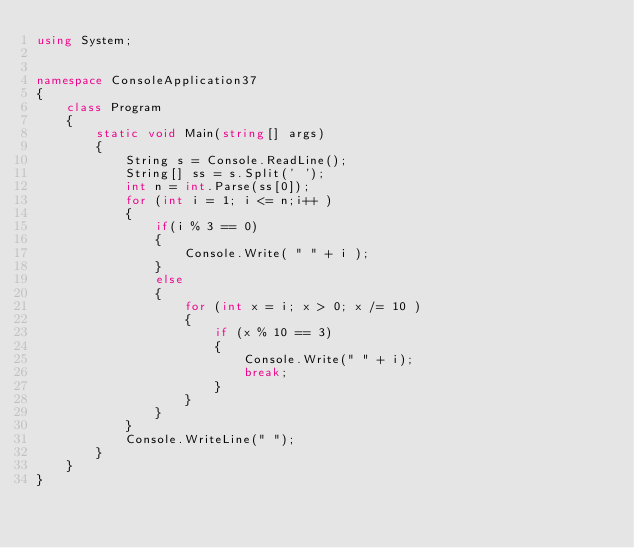<code> <loc_0><loc_0><loc_500><loc_500><_C#_>using System;


namespace ConsoleApplication37
{
    class Program
    {
        static void Main(string[] args)
        {
            String s = Console.ReadLine();
            String[] ss = s.Split(' ');
            int n = int.Parse(ss[0]);
            for (int i = 1; i <= n;i++ )
            {
                if(i % 3 == 0)
                {
                    Console.Write( " " + i );
                }
                else
                {
                    for (int x = i; x > 0; x /= 10 )
                    {
                        if (x % 10 == 3)
                        {
                            Console.Write(" " + i);
                            break;
                        }
                    }
                }
            }
            Console.WriteLine(" ");
        }
    }
}</code> 